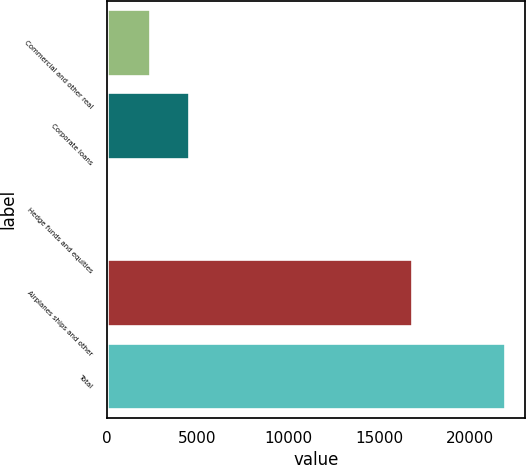Convert chart. <chart><loc_0><loc_0><loc_500><loc_500><bar_chart><fcel>Commercial and other real<fcel>Corporate loans<fcel>Hedge funds and equities<fcel>Airplanes ships and other<fcel>Total<nl><fcel>2368<fcel>4556.9<fcel>54<fcel>16837<fcel>21943<nl></chart> 